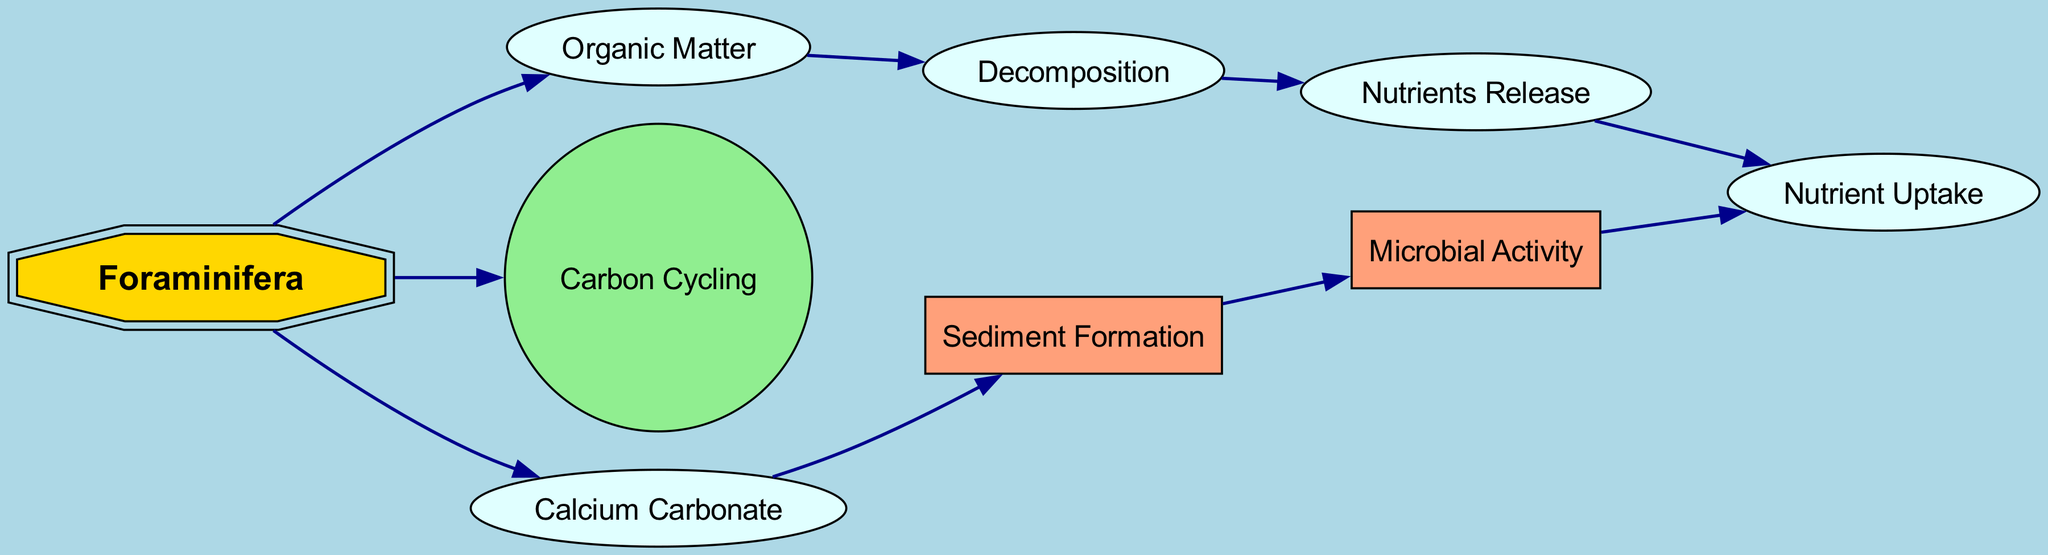What is the primary role of Foraminifera in this nutrient cycling pathway? Foraminifera appears to play a crucial role by contributing to both organic matter processing and carbon cycling. It is the initial node that connects to Organic Matter and Carbon Cycling, indicating its significance in these processes.
Answer: Foraminifera How many nodes are connected to the Nutrient Uptake node? Upon examining the directed graph, we find that Nutrient Uptake is connected to two nodes: Nutrients Release and Microbial Activity. This indicates the interaction via nutrient cycling pathways.
Answer: 2 What process follows Decomposition in the diagram? The diagram shows Decomposition leading to Nutrients Release as the next step in nutrient cycling, indicating a sequential flow.
Answer: Nutrients Release Which node indicates the formation of sediments? Within the diagram, Calcium Carbonate is linked to Sediment Formation, indicating that it represents the process of sediment development.
Answer: Sediment Formation How many edges originate from the Foraminifera node? By analyzing the diagram, we see that there are three edges originating from the Foraminifera node, connecting to Organic Matter, Carbon Cycling, and Calcium Carbonate, showcasing its multiple roles.
Answer: 3 What is the relationship between Microbial Activity and Nutrient Uptake? The directed graph indicates a direct connection from Microbial Activity to Nutrient Uptake, showing that it is involved in facilitating nutrient absorption.
Answer: Direct connection Describe the overall flow of nutrient cycling starting from Organic Matter. Following the flow from Organic Matter to Decomposition, then to Nutrients Release, and eventually leading to Nutrient Uptake, we can see that it represents a systematic pathway of nutrient cycling that supports uptake processes.
Answer: Organic Matter → Decomposition → Nutrients Release → Nutrient Uptake What type of node is used to represent Foraminifera in this graph? Foraminifera is uniquely represented as a double octagon shape filled with gold color, indicating its special role in the nutrient cycling pathways.
Answer: Double octagon Which nodes influence Sediment Formation? The diagram shows that Calcium Carbonate is the only direct predecessor node influencing Sediment Formation, indicating that it is a key contributor to this process.
Answer: Calcium Carbonate 